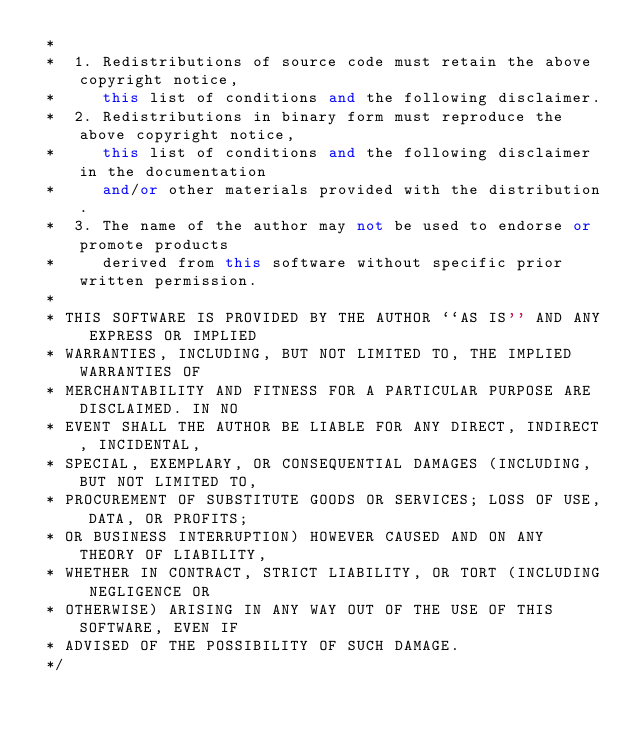<code> <loc_0><loc_0><loc_500><loc_500><_C++_> *
 *  1. Redistributions of source code must retain the above copyright notice,
 *     this list of conditions and the following disclaimer.
 *  2. Redistributions in binary form must reproduce the above copyright notice,
 *     this list of conditions and the following disclaimer in the documentation
 *     and/or other materials provided with the distribution.
 *  3. The name of the author may not be used to endorse or promote products
 *     derived from this software without specific prior written permission.
 *
 * THIS SOFTWARE IS PROVIDED BY THE AUTHOR ``AS IS'' AND ANY EXPRESS OR IMPLIED
 * WARRANTIES, INCLUDING, BUT NOT LIMITED TO, THE IMPLIED WARRANTIES OF
 * MERCHANTABILITY AND FITNESS FOR A PARTICULAR PURPOSE ARE DISCLAIMED. IN NO
 * EVENT SHALL THE AUTHOR BE LIABLE FOR ANY DIRECT, INDIRECT, INCIDENTAL,
 * SPECIAL, EXEMPLARY, OR CONSEQUENTIAL DAMAGES (INCLUDING, BUT NOT LIMITED TO,
 * PROCUREMENT OF SUBSTITUTE GOODS OR SERVICES; LOSS OF USE, DATA, OR PROFITS;
 * OR BUSINESS INTERRUPTION) HOWEVER CAUSED AND ON ANY THEORY OF LIABILITY,
 * WHETHER IN CONTRACT, STRICT LIABILITY, OR TORT (INCLUDING NEGLIGENCE OR
 * OTHERWISE) ARISING IN ANY WAY OUT OF THE USE OF THIS SOFTWARE, EVEN IF
 * ADVISED OF THE POSSIBILITY OF SUCH DAMAGE.
 */
</code> 